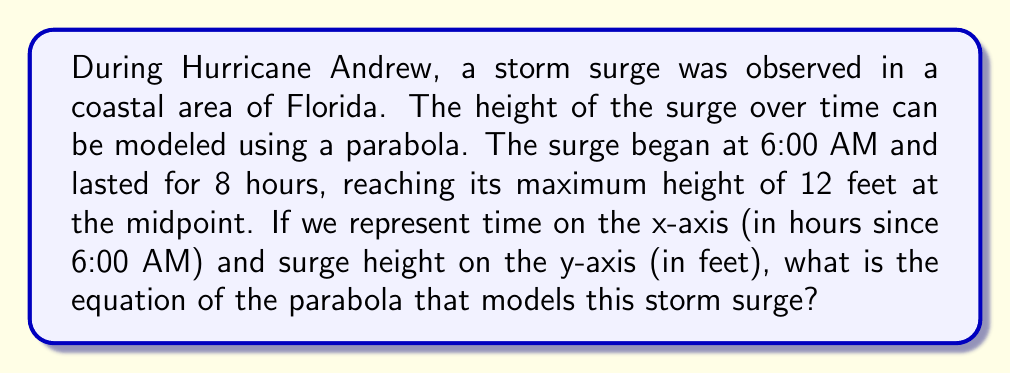Could you help me with this problem? Let's approach this step-by-step:

1) The general equation of a parabola with a vertical axis of symmetry is:
   $$y = a(x - h)^2 + k$$
   where $(h, k)$ is the vertex of the parabola.

2) We know the following:
   - The surge lasts 8 hours, so the x-axis goes from 0 to 8.
   - The maximum height (vertex) occurs at the midpoint, so $h = 4$.
   - The maximum height is 12 feet, so $k = 12$.

3) Our equation is now:
   $$y = a(x - 4)^2 + 12$$

4) To find $a$, we can use the fact that the surge height is 0 at the start (0, 0):
   $$0 = a(0 - 4)^2 + 12$$
   $$0 = 16a + 12$$
   $$-12 = 16a$$
   $$a = -\frac{3}{4}$$

5) Therefore, the final equation is:
   $$y = -\frac{3}{4}(x - 4)^2 + 12$$

This parabola opens downward, has its vertex at (4, 12), and passes through (0, 0) and (8, 0), accurately modeling the storm surge.
Answer: $y = -\frac{3}{4}(x - 4)^2 + 12$ 